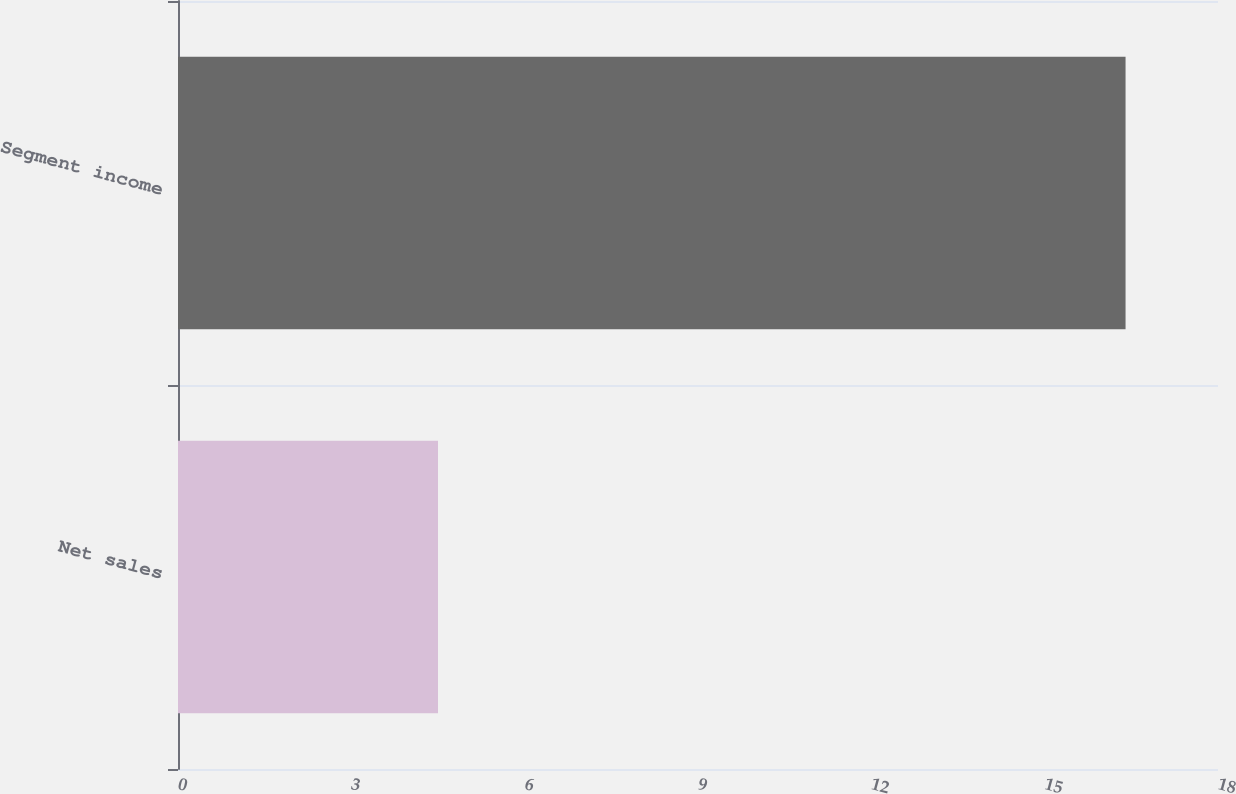<chart> <loc_0><loc_0><loc_500><loc_500><bar_chart><fcel>Net sales<fcel>Segment income<nl><fcel>4.5<fcel>16.4<nl></chart> 